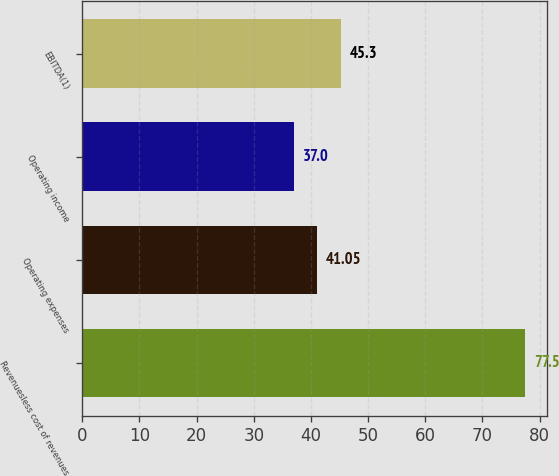Convert chart to OTSL. <chart><loc_0><loc_0><loc_500><loc_500><bar_chart><fcel>Revenuesless cost of revenues<fcel>Operating expenses<fcel>Operating income<fcel>EBITDA(1)<nl><fcel>77.5<fcel>41.05<fcel>37<fcel>45.3<nl></chart> 